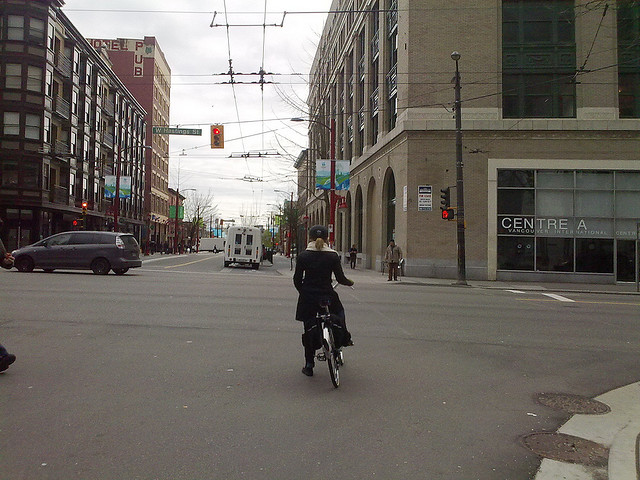What events do you think might happen here during a community festival? During a community festival, this intersection could become a hub of excitement. Stalls and vendors might line the streets, offering food, crafts, and local goods. Performers could entertain the crowd with music, dance, and street performances. Local artists might showcase their work, while children enjoy games and activities specially arranged for them. The street would be filled with laughter, conversation, and a strong sense of community spirit, creating a festive and inclusive atmosphere. Can you elaborate on a specific performance you might see? One specific performance might be a local band setting up on a makeshift stage at the corner of the street. The band, known for their eclectic mix of folk and rock music, attracts a crowd of festival-goers who quickly start dancing and clapping along. The lead singer's soulful voice echoes through the intersection, harmonizing perfectly with the strumming of guitars and the beat of the drums. The performance is lively and engaging, with the band's vibrant energy captivating everyone in the vicinity. As the set continues, the crowd becomes more involved, singing along to familiar tunes and applauding enthusiastically after each song. 